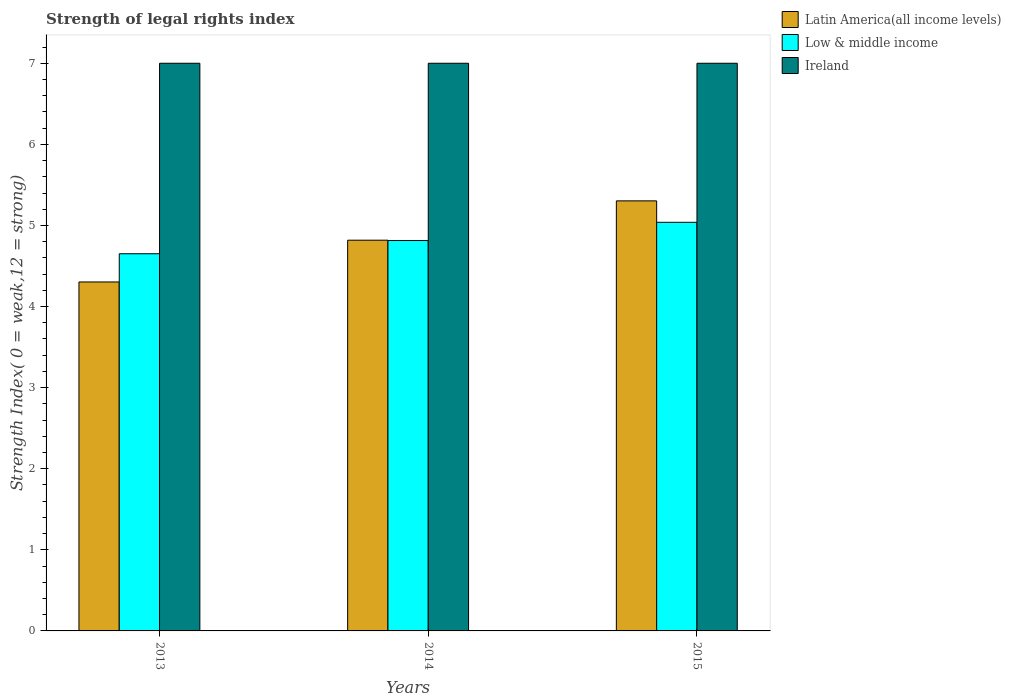How many groups of bars are there?
Ensure brevity in your answer.  3. How many bars are there on the 2nd tick from the left?
Ensure brevity in your answer.  3. How many bars are there on the 1st tick from the right?
Your response must be concise. 3. In how many cases, is the number of bars for a given year not equal to the number of legend labels?
Offer a very short reply. 0. What is the strength index in Ireland in 2014?
Offer a very short reply. 7. Across all years, what is the maximum strength index in Low & middle income?
Your response must be concise. 5.04. Across all years, what is the minimum strength index in Ireland?
Your answer should be compact. 7. In which year was the strength index in Low & middle income maximum?
Offer a very short reply. 2015. What is the total strength index in Latin America(all income levels) in the graph?
Your response must be concise. 14.42. What is the difference between the strength index in Ireland in 2015 and the strength index in Low & middle income in 2014?
Your answer should be compact. 2.19. What is the average strength index in Low & middle income per year?
Your answer should be compact. 4.83. In the year 2015, what is the difference between the strength index in Latin America(all income levels) and strength index in Low & middle income?
Your answer should be compact. 0.26. In how many years, is the strength index in Latin America(all income levels) greater than 6.2?
Offer a very short reply. 0. What is the ratio of the strength index in Latin America(all income levels) in 2013 to that in 2015?
Provide a short and direct response. 0.81. What is the difference between the highest and the second highest strength index in Low & middle income?
Your response must be concise. 0.22. What is the difference between the highest and the lowest strength index in Latin America(all income levels)?
Offer a terse response. 1. Is the sum of the strength index in Low & middle income in 2014 and 2015 greater than the maximum strength index in Latin America(all income levels) across all years?
Provide a succinct answer. Yes. What does the 1st bar from the left in 2015 represents?
Give a very brief answer. Latin America(all income levels). What does the 1st bar from the right in 2013 represents?
Provide a succinct answer. Ireland. How many years are there in the graph?
Offer a very short reply. 3. What is the difference between two consecutive major ticks on the Y-axis?
Your answer should be compact. 1. Does the graph contain any zero values?
Make the answer very short. No. Where does the legend appear in the graph?
Your response must be concise. Top right. How are the legend labels stacked?
Provide a succinct answer. Vertical. What is the title of the graph?
Give a very brief answer. Strength of legal rights index. What is the label or title of the Y-axis?
Give a very brief answer. Strength Index( 0 = weak,12 = strong). What is the Strength Index( 0 = weak,12 = strong) of Latin America(all income levels) in 2013?
Give a very brief answer. 4.3. What is the Strength Index( 0 = weak,12 = strong) in Low & middle income in 2013?
Keep it short and to the point. 4.65. What is the Strength Index( 0 = weak,12 = strong) in Latin America(all income levels) in 2014?
Make the answer very short. 4.82. What is the Strength Index( 0 = weak,12 = strong) of Low & middle income in 2014?
Your answer should be very brief. 4.81. What is the Strength Index( 0 = weak,12 = strong) of Ireland in 2014?
Offer a very short reply. 7. What is the Strength Index( 0 = weak,12 = strong) in Latin America(all income levels) in 2015?
Give a very brief answer. 5.3. What is the Strength Index( 0 = weak,12 = strong) in Low & middle income in 2015?
Provide a succinct answer. 5.04. Across all years, what is the maximum Strength Index( 0 = weak,12 = strong) of Latin America(all income levels)?
Provide a short and direct response. 5.3. Across all years, what is the maximum Strength Index( 0 = weak,12 = strong) of Low & middle income?
Make the answer very short. 5.04. Across all years, what is the maximum Strength Index( 0 = weak,12 = strong) of Ireland?
Give a very brief answer. 7. Across all years, what is the minimum Strength Index( 0 = weak,12 = strong) of Latin America(all income levels)?
Give a very brief answer. 4.3. Across all years, what is the minimum Strength Index( 0 = weak,12 = strong) of Low & middle income?
Give a very brief answer. 4.65. Across all years, what is the minimum Strength Index( 0 = weak,12 = strong) in Ireland?
Give a very brief answer. 7. What is the total Strength Index( 0 = weak,12 = strong) in Latin America(all income levels) in the graph?
Give a very brief answer. 14.42. What is the total Strength Index( 0 = weak,12 = strong) in Low & middle income in the graph?
Provide a short and direct response. 14.5. What is the difference between the Strength Index( 0 = weak,12 = strong) in Latin America(all income levels) in 2013 and that in 2014?
Ensure brevity in your answer.  -0.52. What is the difference between the Strength Index( 0 = weak,12 = strong) in Low & middle income in 2013 and that in 2014?
Ensure brevity in your answer.  -0.16. What is the difference between the Strength Index( 0 = weak,12 = strong) of Low & middle income in 2013 and that in 2015?
Offer a terse response. -0.39. What is the difference between the Strength Index( 0 = weak,12 = strong) in Latin America(all income levels) in 2014 and that in 2015?
Provide a short and direct response. -0.48. What is the difference between the Strength Index( 0 = weak,12 = strong) of Low & middle income in 2014 and that in 2015?
Your answer should be very brief. -0.22. What is the difference between the Strength Index( 0 = weak,12 = strong) in Latin America(all income levels) in 2013 and the Strength Index( 0 = weak,12 = strong) in Low & middle income in 2014?
Your answer should be very brief. -0.51. What is the difference between the Strength Index( 0 = weak,12 = strong) of Latin America(all income levels) in 2013 and the Strength Index( 0 = weak,12 = strong) of Ireland in 2014?
Your response must be concise. -2.7. What is the difference between the Strength Index( 0 = weak,12 = strong) of Low & middle income in 2013 and the Strength Index( 0 = weak,12 = strong) of Ireland in 2014?
Your answer should be compact. -2.35. What is the difference between the Strength Index( 0 = weak,12 = strong) in Latin America(all income levels) in 2013 and the Strength Index( 0 = weak,12 = strong) in Low & middle income in 2015?
Provide a short and direct response. -0.74. What is the difference between the Strength Index( 0 = weak,12 = strong) in Latin America(all income levels) in 2013 and the Strength Index( 0 = weak,12 = strong) in Ireland in 2015?
Your answer should be compact. -2.7. What is the difference between the Strength Index( 0 = weak,12 = strong) in Low & middle income in 2013 and the Strength Index( 0 = weak,12 = strong) in Ireland in 2015?
Your answer should be very brief. -2.35. What is the difference between the Strength Index( 0 = weak,12 = strong) of Latin America(all income levels) in 2014 and the Strength Index( 0 = weak,12 = strong) of Low & middle income in 2015?
Offer a terse response. -0.22. What is the difference between the Strength Index( 0 = weak,12 = strong) of Latin America(all income levels) in 2014 and the Strength Index( 0 = weak,12 = strong) of Ireland in 2015?
Provide a succinct answer. -2.18. What is the difference between the Strength Index( 0 = weak,12 = strong) of Low & middle income in 2014 and the Strength Index( 0 = weak,12 = strong) of Ireland in 2015?
Your answer should be very brief. -2.19. What is the average Strength Index( 0 = weak,12 = strong) in Latin America(all income levels) per year?
Give a very brief answer. 4.81. What is the average Strength Index( 0 = weak,12 = strong) in Low & middle income per year?
Provide a succinct answer. 4.83. In the year 2013, what is the difference between the Strength Index( 0 = weak,12 = strong) of Latin America(all income levels) and Strength Index( 0 = weak,12 = strong) of Low & middle income?
Make the answer very short. -0.35. In the year 2013, what is the difference between the Strength Index( 0 = weak,12 = strong) of Latin America(all income levels) and Strength Index( 0 = weak,12 = strong) of Ireland?
Provide a short and direct response. -2.7. In the year 2013, what is the difference between the Strength Index( 0 = weak,12 = strong) of Low & middle income and Strength Index( 0 = weak,12 = strong) of Ireland?
Give a very brief answer. -2.35. In the year 2014, what is the difference between the Strength Index( 0 = weak,12 = strong) of Latin America(all income levels) and Strength Index( 0 = weak,12 = strong) of Low & middle income?
Your answer should be very brief. 0. In the year 2014, what is the difference between the Strength Index( 0 = weak,12 = strong) of Latin America(all income levels) and Strength Index( 0 = weak,12 = strong) of Ireland?
Provide a short and direct response. -2.18. In the year 2014, what is the difference between the Strength Index( 0 = weak,12 = strong) in Low & middle income and Strength Index( 0 = weak,12 = strong) in Ireland?
Your answer should be very brief. -2.19. In the year 2015, what is the difference between the Strength Index( 0 = weak,12 = strong) in Latin America(all income levels) and Strength Index( 0 = weak,12 = strong) in Low & middle income?
Offer a very short reply. 0.26. In the year 2015, what is the difference between the Strength Index( 0 = weak,12 = strong) of Latin America(all income levels) and Strength Index( 0 = weak,12 = strong) of Ireland?
Offer a very short reply. -1.7. In the year 2015, what is the difference between the Strength Index( 0 = weak,12 = strong) in Low & middle income and Strength Index( 0 = weak,12 = strong) in Ireland?
Make the answer very short. -1.96. What is the ratio of the Strength Index( 0 = weak,12 = strong) of Latin America(all income levels) in 2013 to that in 2014?
Offer a very short reply. 0.89. What is the ratio of the Strength Index( 0 = weak,12 = strong) of Low & middle income in 2013 to that in 2014?
Give a very brief answer. 0.97. What is the ratio of the Strength Index( 0 = weak,12 = strong) in Latin America(all income levels) in 2013 to that in 2015?
Ensure brevity in your answer.  0.81. What is the ratio of the Strength Index( 0 = weak,12 = strong) of Ireland in 2013 to that in 2015?
Ensure brevity in your answer.  1. What is the ratio of the Strength Index( 0 = weak,12 = strong) in Latin America(all income levels) in 2014 to that in 2015?
Give a very brief answer. 0.91. What is the ratio of the Strength Index( 0 = weak,12 = strong) of Low & middle income in 2014 to that in 2015?
Provide a succinct answer. 0.96. What is the ratio of the Strength Index( 0 = weak,12 = strong) in Ireland in 2014 to that in 2015?
Offer a very short reply. 1. What is the difference between the highest and the second highest Strength Index( 0 = weak,12 = strong) of Latin America(all income levels)?
Offer a very short reply. 0.48. What is the difference between the highest and the second highest Strength Index( 0 = weak,12 = strong) in Low & middle income?
Your answer should be very brief. 0.22. What is the difference between the highest and the second highest Strength Index( 0 = weak,12 = strong) of Ireland?
Your answer should be very brief. 0. What is the difference between the highest and the lowest Strength Index( 0 = weak,12 = strong) of Latin America(all income levels)?
Make the answer very short. 1. What is the difference between the highest and the lowest Strength Index( 0 = weak,12 = strong) in Low & middle income?
Your answer should be compact. 0.39. 